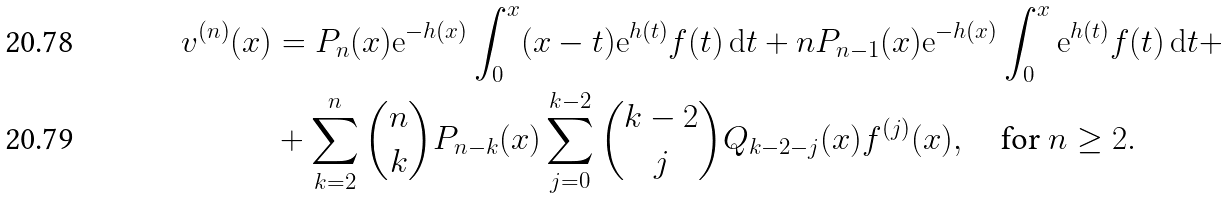Convert formula to latex. <formula><loc_0><loc_0><loc_500><loc_500>v ^ { ( n ) } ( x ) & = P _ { n } ( x ) \mathrm e ^ { - h ( x ) } \int _ { 0 } ^ { x } ( x - t ) \mathrm e ^ { h ( t ) } f ( t ) \, \mathrm d t + n P _ { n - 1 } ( x ) \mathrm e ^ { - h ( x ) } \int _ { 0 } ^ { x } \mathrm e ^ { h ( t ) } f ( t ) \, \mathrm d t + \\ & + \sum _ { k = 2 } ^ { n } \binom { n } { k } P _ { n - k } ( x ) \sum _ { j = 0 } ^ { k - 2 } \binom { k - 2 } { j } Q _ { k - 2 - j } ( x ) f ^ { ( j ) } ( x ) , \quad \text {\upshape for $n\geq 2$} .</formula> 